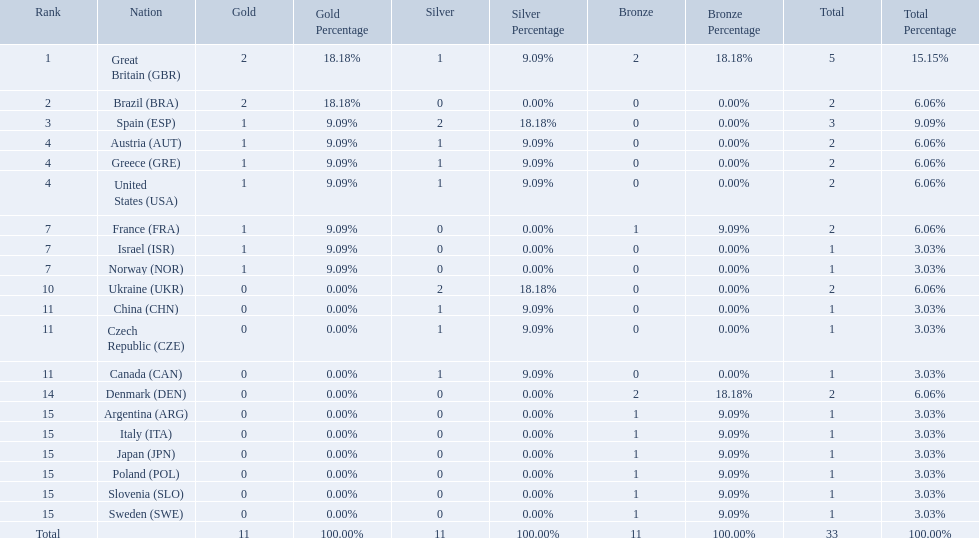How many medals did each country receive? 5, 2, 3, 2, 2, 2, 2, 1, 1, 2, 1, 1, 1, 2, 1, 1, 1, 1, 1, 1. Which country received 3 medals? Spain (ESP). How many medals did spain gain 3. Only country that got more medals? Spain (ESP). 